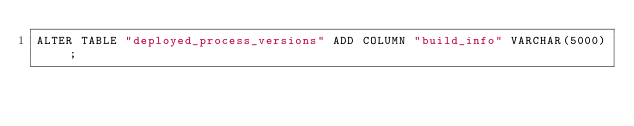Convert code to text. <code><loc_0><loc_0><loc_500><loc_500><_SQL_>ALTER TABLE "deployed_process_versions" ADD COLUMN "build_info" VARCHAR(5000);
</code> 